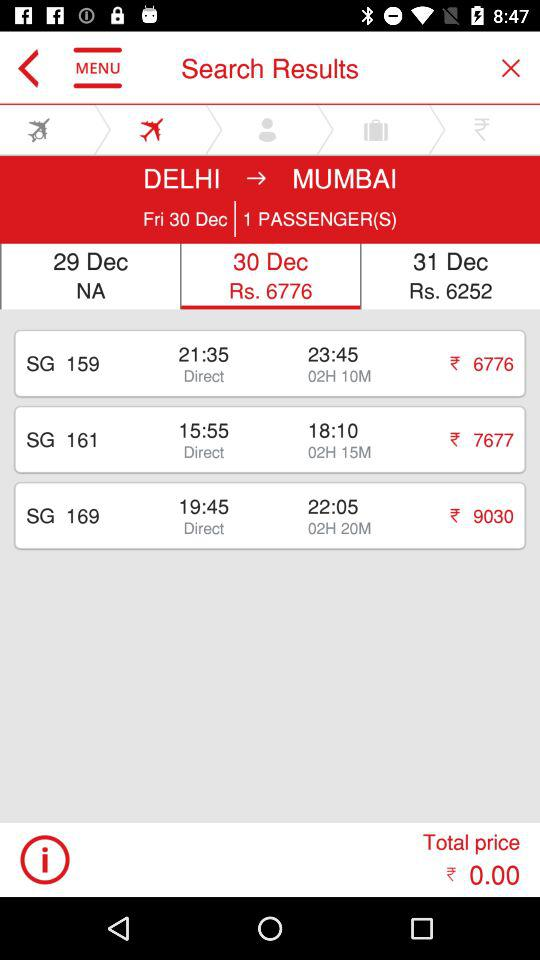How many more flights are there than passengers?
Answer the question using a single word or phrase. 2 